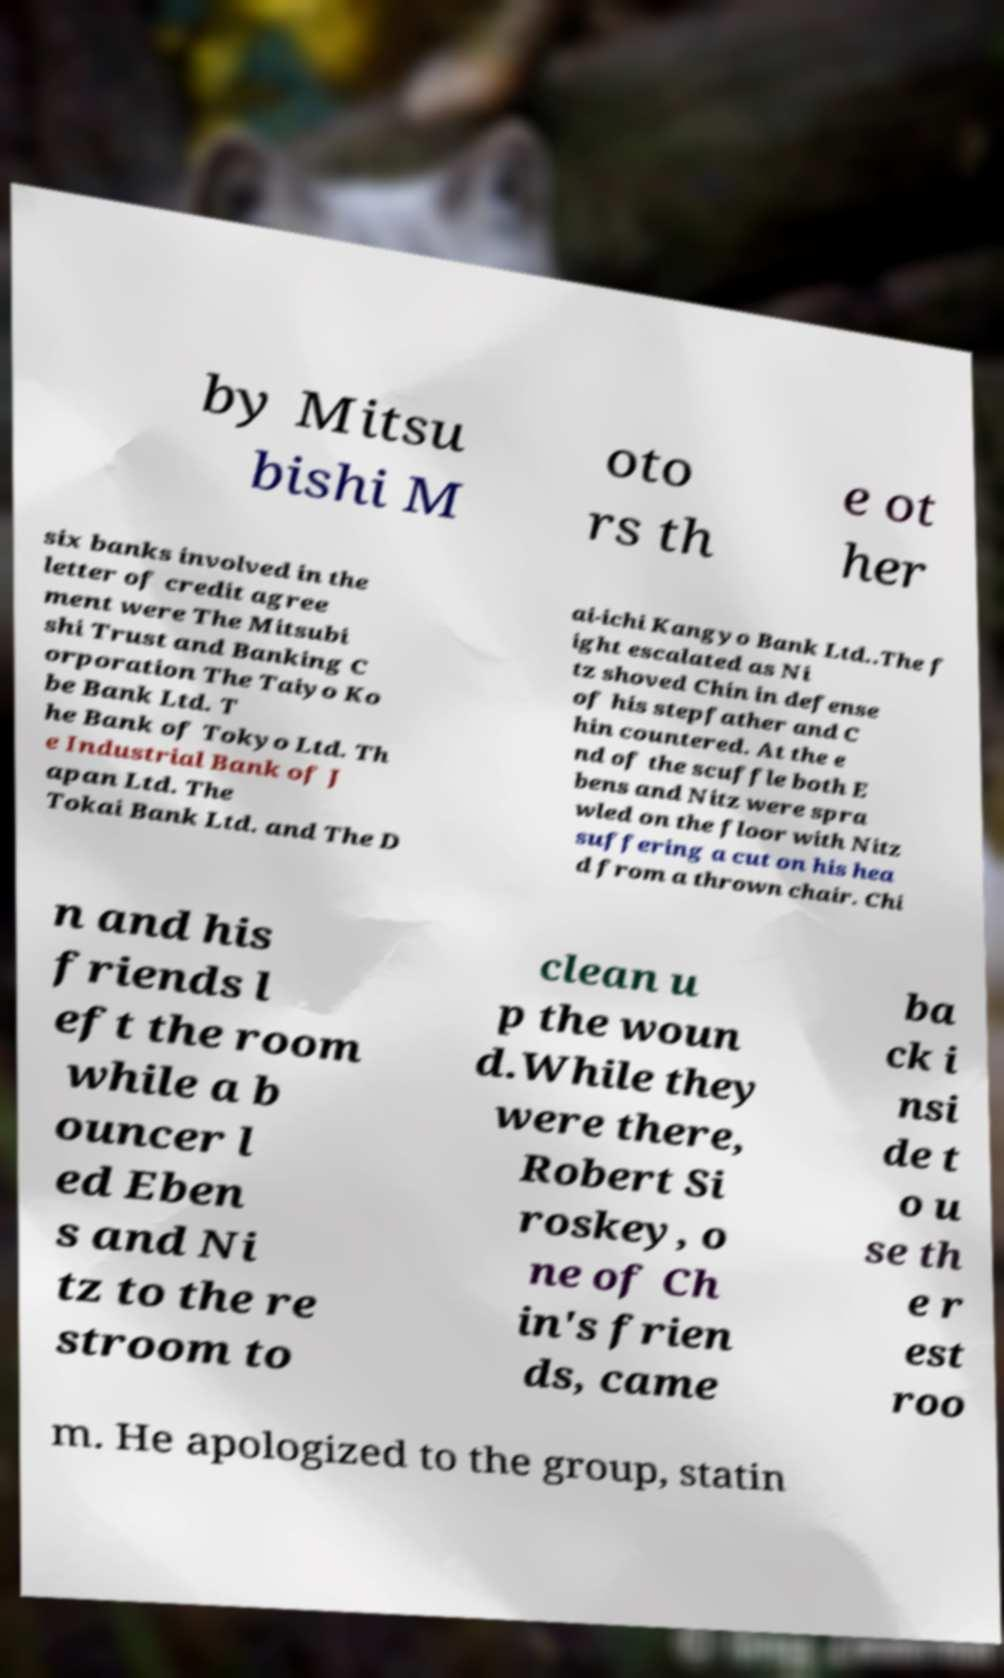For documentation purposes, I need the text within this image transcribed. Could you provide that? by Mitsu bishi M oto rs th e ot her six banks involved in the letter of credit agree ment were The Mitsubi shi Trust and Banking C orporation The Taiyo Ko be Bank Ltd. T he Bank of Tokyo Ltd. Th e Industrial Bank of J apan Ltd. The Tokai Bank Ltd. and The D ai-ichi Kangyo Bank Ltd..The f ight escalated as Ni tz shoved Chin in defense of his stepfather and C hin countered. At the e nd of the scuffle both E bens and Nitz were spra wled on the floor with Nitz suffering a cut on his hea d from a thrown chair. Chi n and his friends l eft the room while a b ouncer l ed Eben s and Ni tz to the re stroom to clean u p the woun d.While they were there, Robert Si roskey, o ne of Ch in's frien ds, came ba ck i nsi de t o u se th e r est roo m. He apologized to the group, statin 